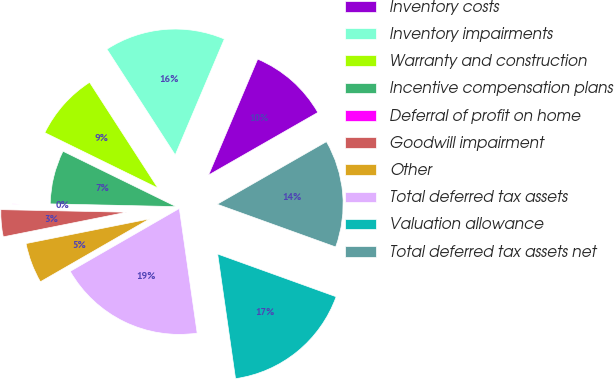Convert chart. <chart><loc_0><loc_0><loc_500><loc_500><pie_chart><fcel>Inventory costs<fcel>Inventory impairments<fcel>Warranty and construction<fcel>Incentive compensation plans<fcel>Deferral of profit on home<fcel>Goodwill impairment<fcel>Other<fcel>Total deferred tax assets<fcel>Valuation allowance<fcel>Total deferred tax assets net<nl><fcel>10.34%<fcel>15.5%<fcel>8.62%<fcel>6.9%<fcel>0.02%<fcel>3.46%<fcel>5.18%<fcel>18.94%<fcel>17.22%<fcel>13.78%<nl></chart> 